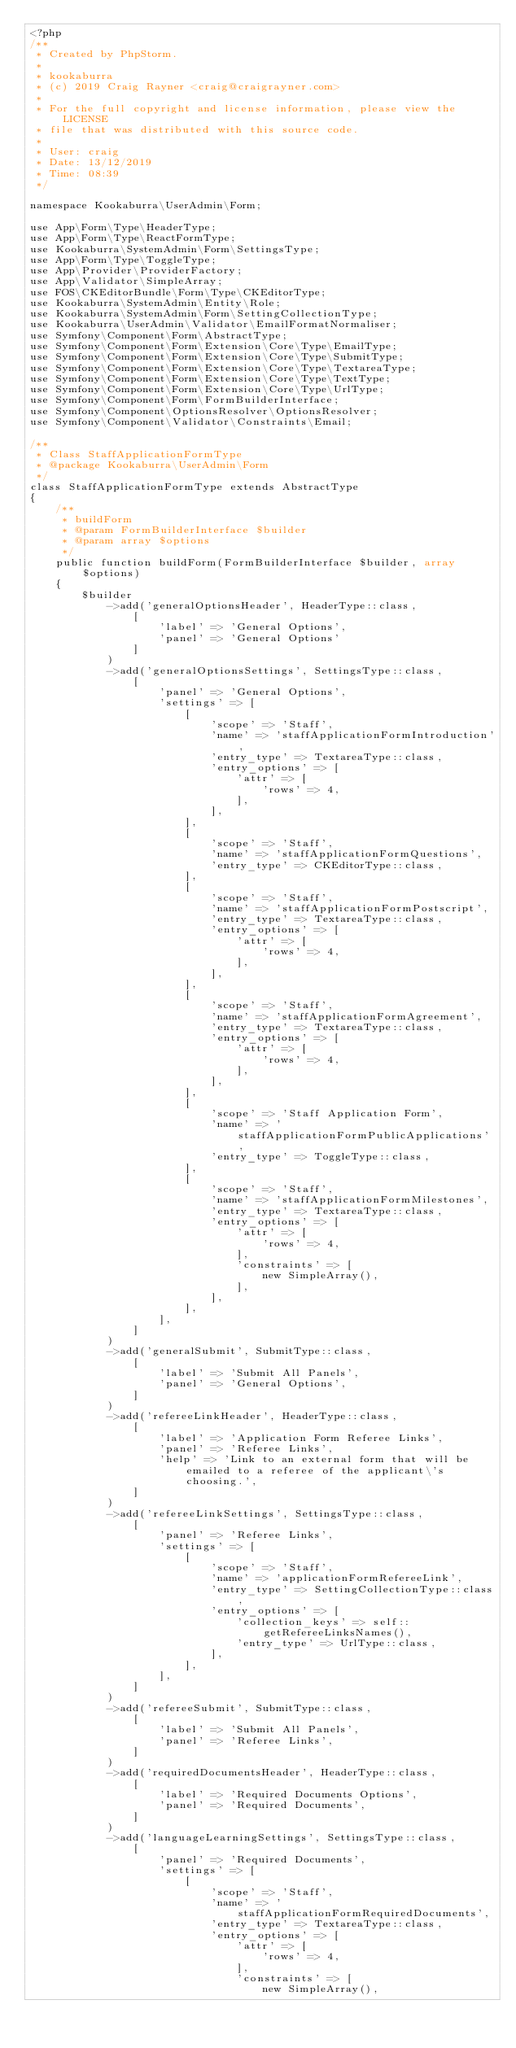Convert code to text. <code><loc_0><loc_0><loc_500><loc_500><_PHP_><?php
/**
 * Created by PhpStorm.
 *
 * kookaburra
 * (c) 2019 Craig Rayner <craig@craigrayner.com>
 *
 * For the full copyright and license information, please view the LICENSE
 * file that was distributed with this source code.
 *
 * User: craig
 * Date: 13/12/2019
 * Time: 08:39
 */

namespace Kookaburra\UserAdmin\Form;

use App\Form\Type\HeaderType;
use App\Form\Type\ReactFormType;
use Kookaburra\SystemAdmin\Form\SettingsType;
use App\Form\Type\ToggleType;
use App\Provider\ProviderFactory;
use App\Validator\SimpleArray;
use FOS\CKEditorBundle\Form\Type\CKEditorType;
use Kookaburra\SystemAdmin\Entity\Role;
use Kookaburra\SystemAdmin\Form\SettingCollectionType;
use Kookaburra\UserAdmin\Validator\EmailFormatNormaliser;
use Symfony\Component\Form\AbstractType;
use Symfony\Component\Form\Extension\Core\Type\EmailType;
use Symfony\Component\Form\Extension\Core\Type\SubmitType;
use Symfony\Component\Form\Extension\Core\Type\TextareaType;
use Symfony\Component\Form\Extension\Core\Type\TextType;
use Symfony\Component\Form\Extension\Core\Type\UrlType;
use Symfony\Component\Form\FormBuilderInterface;
use Symfony\Component\OptionsResolver\OptionsResolver;
use Symfony\Component\Validator\Constraints\Email;

/**
 * Class StaffApplicationFormType
 * @package Kookaburra\UserAdmin\Form
 */
class StaffApplicationFormType extends AbstractType
{
    /**
     * buildForm
     * @param FormBuilderInterface $builder
     * @param array $options
     */
    public function buildForm(FormBuilderInterface $builder, array $options)
    {
        $builder
            ->add('generalOptionsHeader', HeaderType::class,
                [
                    'label' => 'General Options',
                    'panel' => 'General Options'
                ]
            )
            ->add('generalOptionsSettings', SettingsType::class,
                [
                    'panel' => 'General Options',
                    'settings' => [
                        [
                            'scope' => 'Staff',
                            'name' => 'staffApplicationFormIntroduction',
                            'entry_type' => TextareaType::class,
                            'entry_options' => [
                                'attr' => [
                                    'rows' => 4,
                                ],
                            ],
                        ],
                        [
                            'scope' => 'Staff',
                            'name' => 'staffApplicationFormQuestions',
                            'entry_type' => CKEditorType::class,
                        ],
                        [
                            'scope' => 'Staff',
                            'name' => 'staffApplicationFormPostscript',
                            'entry_type' => TextareaType::class,
                            'entry_options' => [
                                'attr' => [
                                    'rows' => 4,
                                ],
                            ],
                        ],
                        [
                            'scope' => 'Staff',
                            'name' => 'staffApplicationFormAgreement',
                            'entry_type' => TextareaType::class,
                            'entry_options' => [
                                'attr' => [
                                    'rows' => 4,
                                ],
                            ],
                        ],
                        [
                            'scope' => 'Staff Application Form',
                            'name' => 'staffApplicationFormPublicApplications',
                            'entry_type' => ToggleType::class,
                        ],
                        [
                            'scope' => 'Staff',
                            'name' => 'staffApplicationFormMilestones',
                            'entry_type' => TextareaType::class,
                            'entry_options' => [
                                'attr' => [
                                    'rows' => 4,
                                ],
                                'constraints' => [
                                    new SimpleArray(),
                                ],
                            ],
                        ],
                    ],
                ]
            )
            ->add('generalSubmit', SubmitType::class,
                [
                    'label' => 'Submit All Panels',
                    'panel' => 'General Options',
                ]
            )
            ->add('refereeLinkHeader', HeaderType::class,
                [
                    'label' => 'Application Form Referee Links',
                    'panel' => 'Referee Links',
                    'help' => 'Link to an external form that will be emailed to a referee of the applicant\'s choosing.',
                ]
            )
            ->add('refereeLinkSettings', SettingsType::class,
                [
                    'panel' => 'Referee Links',
                    'settings' => [
                        [
                            'scope' => 'Staff',
                            'name' => 'applicationFormRefereeLink',
                            'entry_type' => SettingCollectionType::class,
                            'entry_options' => [
                                'collection_keys' => self::getRefereeLinksNames(),
                                'entry_type' => UrlType::class,
                            ],
                        ],
                    ],
                ]
            )
            ->add('refereeSubmit', SubmitType::class,
                [
                    'label' => 'Submit All Panels',
                    'panel' => 'Referee Links',
                ]
            )
            ->add('requiredDocumentsHeader', HeaderType::class,
                [
                    'label' => 'Required Documents Options',
                    'panel' => 'Required Documents',
                ]
            )
            ->add('languageLearningSettings', SettingsType::class,
                [
                    'panel' => 'Required Documents',
                    'settings' => [
                        [
                            'scope' => 'Staff',
                            'name' => 'staffApplicationFormRequiredDocuments',
                            'entry_type' => TextareaType::class,
                            'entry_options' => [
                                'attr' => [
                                    'rows' => 4,
                                ],
                                'constraints' => [
                                    new SimpleArray(),</code> 